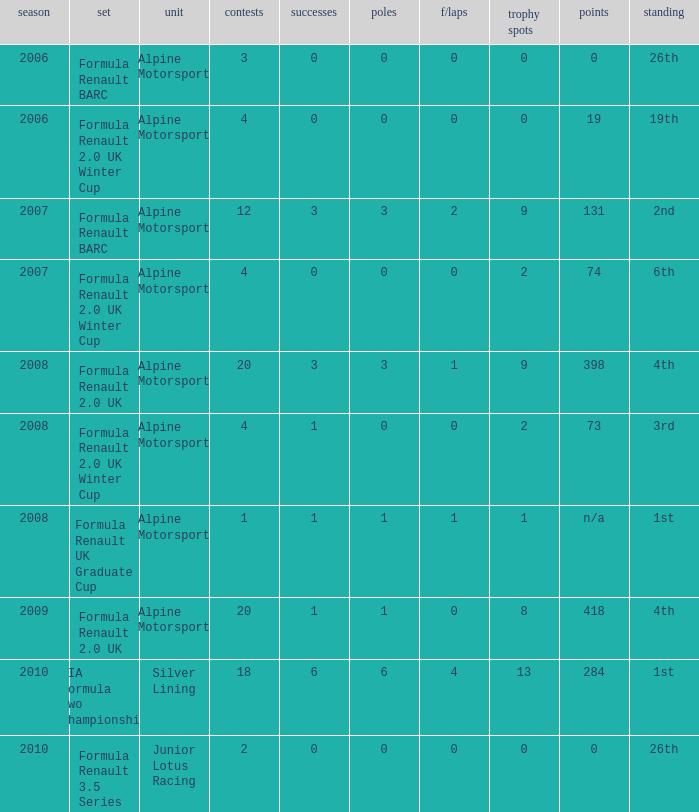How much were the f/laps if poles is higher than 1.0 during 2008? 1.0. 